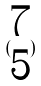<formula> <loc_0><loc_0><loc_500><loc_500>( \begin{matrix} 7 \\ 5 \end{matrix} )</formula> 